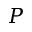Convert formula to latex. <formula><loc_0><loc_0><loc_500><loc_500>P</formula> 